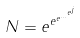Convert formula to latex. <formula><loc_0><loc_0><loc_500><loc_500>N = e ^ { e ^ { e ^ { \dots ^ { e ^ { j } } } } }</formula> 